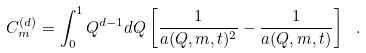<formula> <loc_0><loc_0><loc_500><loc_500>C ^ { ( d ) } _ { m } = \int _ { 0 } ^ { 1 } Q ^ { d - 1 } d Q \left [ \frac { 1 } { a ( { Q } , m , t ) ^ { 2 } } - \frac { 1 } { a ( { Q } , m , t ) } \right ] \ .</formula> 